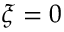Convert formula to latex. <formula><loc_0><loc_0><loc_500><loc_500>\xi = 0</formula> 